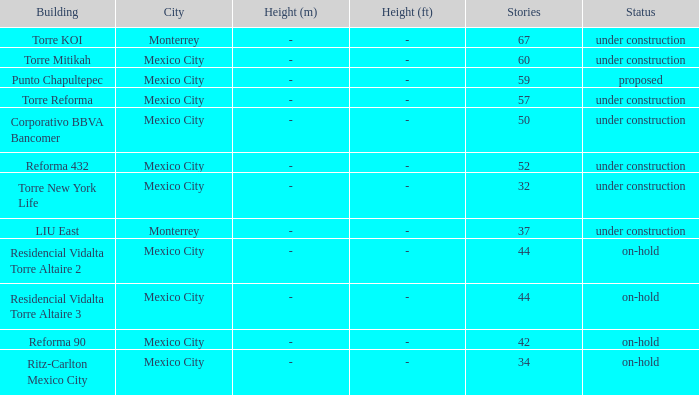How tall is the 52 story building? M (ft). 